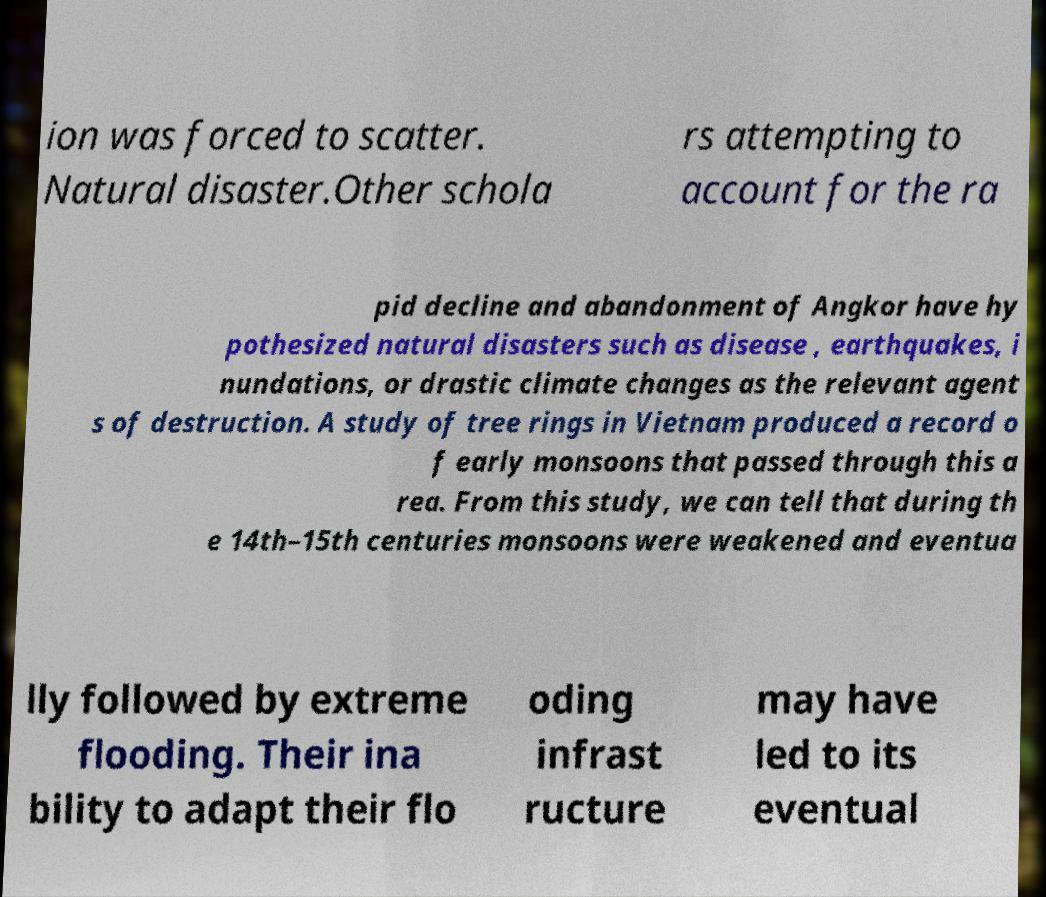I need the written content from this picture converted into text. Can you do that? ion was forced to scatter. Natural disaster.Other schola rs attempting to account for the ra pid decline and abandonment of Angkor have hy pothesized natural disasters such as disease , earthquakes, i nundations, or drastic climate changes as the relevant agent s of destruction. A study of tree rings in Vietnam produced a record o f early monsoons that passed through this a rea. From this study, we can tell that during th e 14th–15th centuries monsoons were weakened and eventua lly followed by extreme flooding. Their ina bility to adapt their flo oding infrast ructure may have led to its eventual 